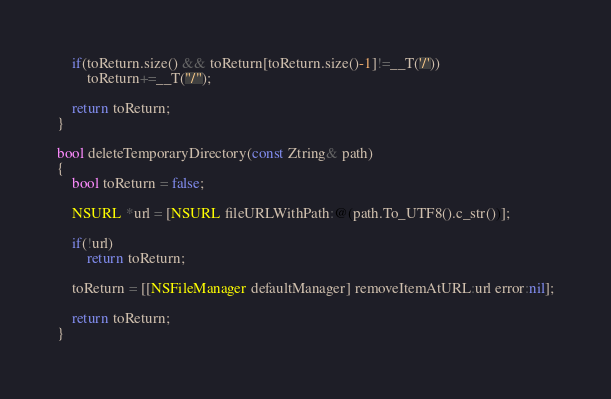<code> <loc_0><loc_0><loc_500><loc_500><_ObjectiveC_>    if(toReturn.size() && toReturn[toReturn.size()-1]!=__T('/'))
        toReturn+=__T("/");

    return toReturn;
}

bool deleteTemporaryDirectory(const Ztring& path)
{
    bool toReturn = false;

    NSURL *url = [NSURL fileURLWithPath:@(path.To_UTF8().c_str())];

    if(!url)
        return toReturn;

    toReturn = [[NSFileManager defaultManager] removeItemAtURL:url error:nil];

    return toReturn;
}
</code> 